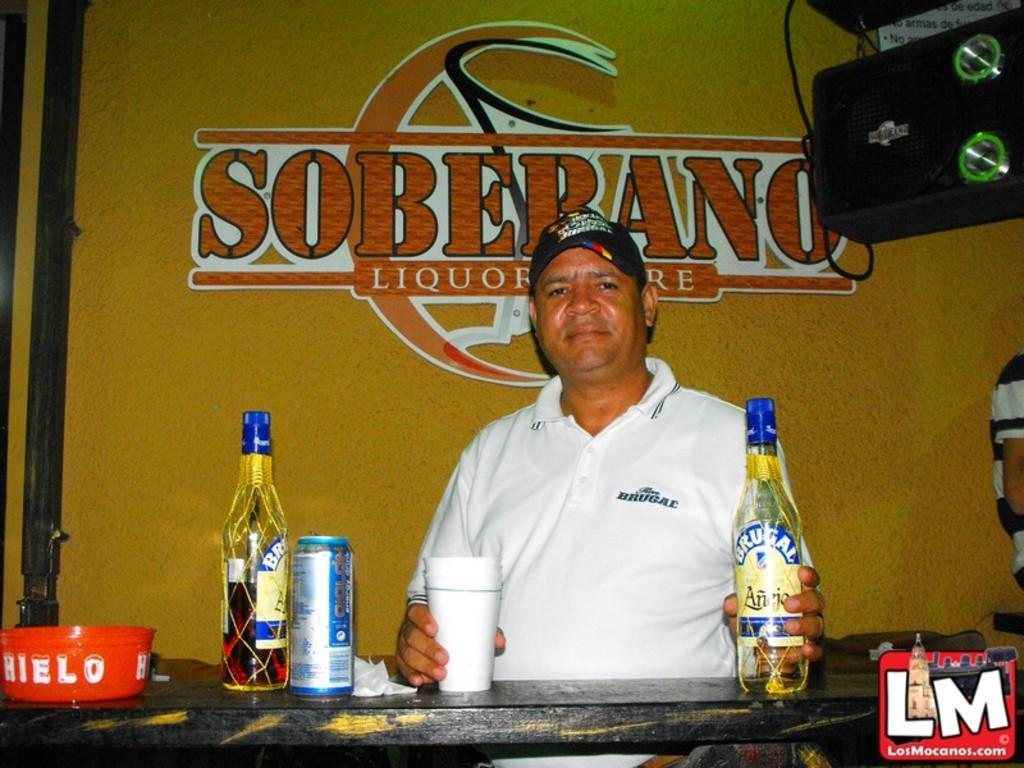<image>
Create a compact narrative representing the image presented. A man sits in front of sign that reads Soberano Liquor 